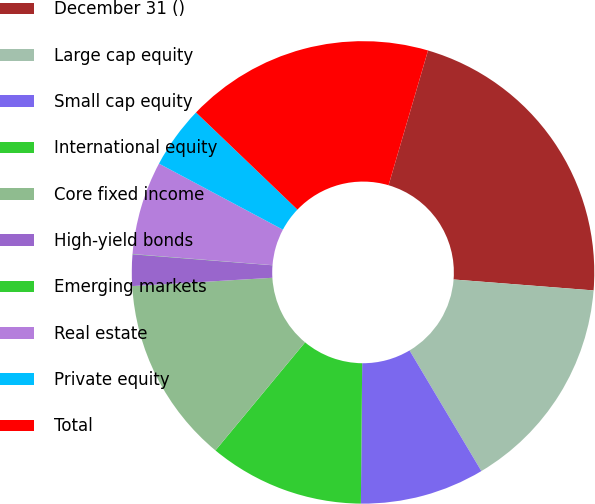<chart> <loc_0><loc_0><loc_500><loc_500><pie_chart><fcel>December 31 ()<fcel>Large cap equity<fcel>Small cap equity<fcel>International equity<fcel>Core fixed income<fcel>High-yield bonds<fcel>Emerging markets<fcel>Real estate<fcel>Private equity<fcel>Total<nl><fcel>21.71%<fcel>15.21%<fcel>8.7%<fcel>10.87%<fcel>13.04%<fcel>2.19%<fcel>0.02%<fcel>6.53%<fcel>4.36%<fcel>17.38%<nl></chart> 